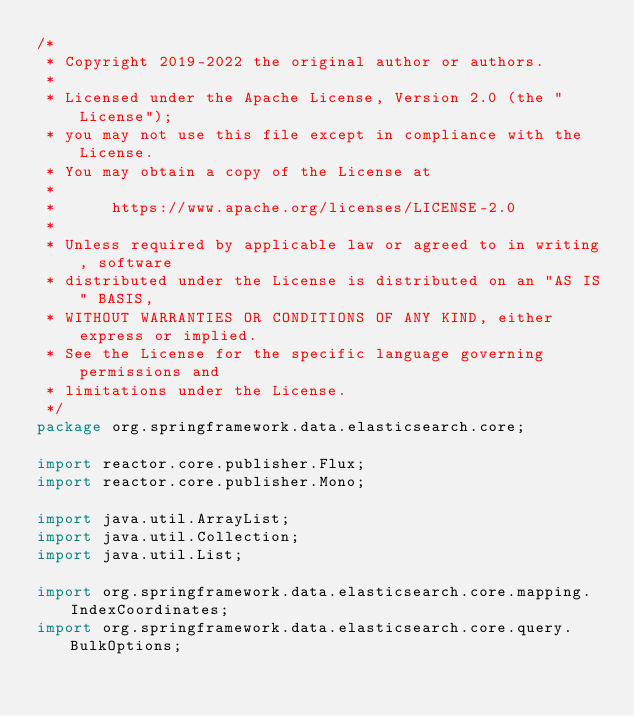Convert code to text. <code><loc_0><loc_0><loc_500><loc_500><_Java_>/*
 * Copyright 2019-2022 the original author or authors.
 *
 * Licensed under the Apache License, Version 2.0 (the "License");
 * you may not use this file except in compliance with the License.
 * You may obtain a copy of the License at
 *
 *      https://www.apache.org/licenses/LICENSE-2.0
 *
 * Unless required by applicable law or agreed to in writing, software
 * distributed under the License is distributed on an "AS IS" BASIS,
 * WITHOUT WARRANTIES OR CONDITIONS OF ANY KIND, either express or implied.
 * See the License for the specific language governing permissions and
 * limitations under the License.
 */
package org.springframework.data.elasticsearch.core;

import reactor.core.publisher.Flux;
import reactor.core.publisher.Mono;

import java.util.ArrayList;
import java.util.Collection;
import java.util.List;

import org.springframework.data.elasticsearch.core.mapping.IndexCoordinates;
import org.springframework.data.elasticsearch.core.query.BulkOptions;</code> 